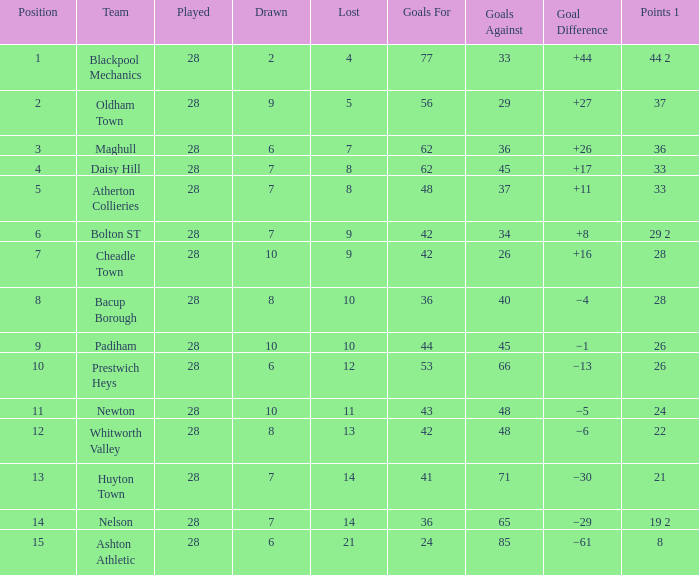Can you give me this table as a dict? {'header': ['Position', 'Team', 'Played', 'Drawn', 'Lost', 'Goals For', 'Goals Against', 'Goal Difference', 'Points 1'], 'rows': [['1', 'Blackpool Mechanics', '28', '2', '4', '77', '33', '+44', '44 2'], ['2', 'Oldham Town', '28', '9', '5', '56', '29', '+27', '37'], ['3', 'Maghull', '28', '6', '7', '62', '36', '+26', '36'], ['4', 'Daisy Hill', '28', '7', '8', '62', '45', '+17', '33'], ['5', 'Atherton Collieries', '28', '7', '8', '48', '37', '+11', '33'], ['6', 'Bolton ST', '28', '7', '9', '42', '34', '+8', '29 2'], ['7', 'Cheadle Town', '28', '10', '9', '42', '26', '+16', '28'], ['8', 'Bacup Borough', '28', '8', '10', '36', '40', '−4', '28'], ['9', 'Padiham', '28', '10', '10', '44', '45', '−1', '26'], ['10', 'Prestwich Heys', '28', '6', '12', '53', '66', '−13', '26'], ['11', 'Newton', '28', '10', '11', '43', '48', '−5', '24'], ['12', 'Whitworth Valley', '28', '8', '13', '42', '48', '−6', '22'], ['13', 'Huyton Town', '28', '7', '14', '41', '71', '−30', '21'], ['14', 'Nelson', '28', '7', '14', '36', '65', '−29', '19 2'], ['15', 'Ashton Athletic', '28', '6', '21', '24', '85', '−61', '8']]} What is the mean played for entries with less than 65 goals against, points 1 of 19 2, and a rank above 15? None. 